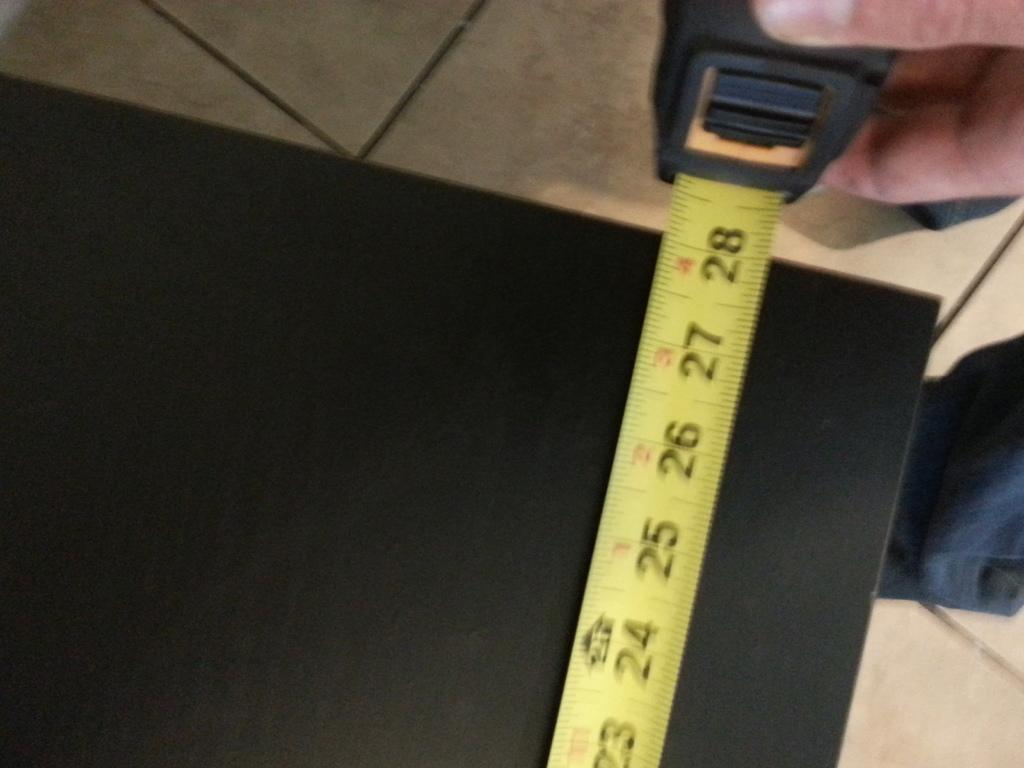<image>
Present a compact description of the photo's key features. The tape measure is measuring just past 28 inches. 